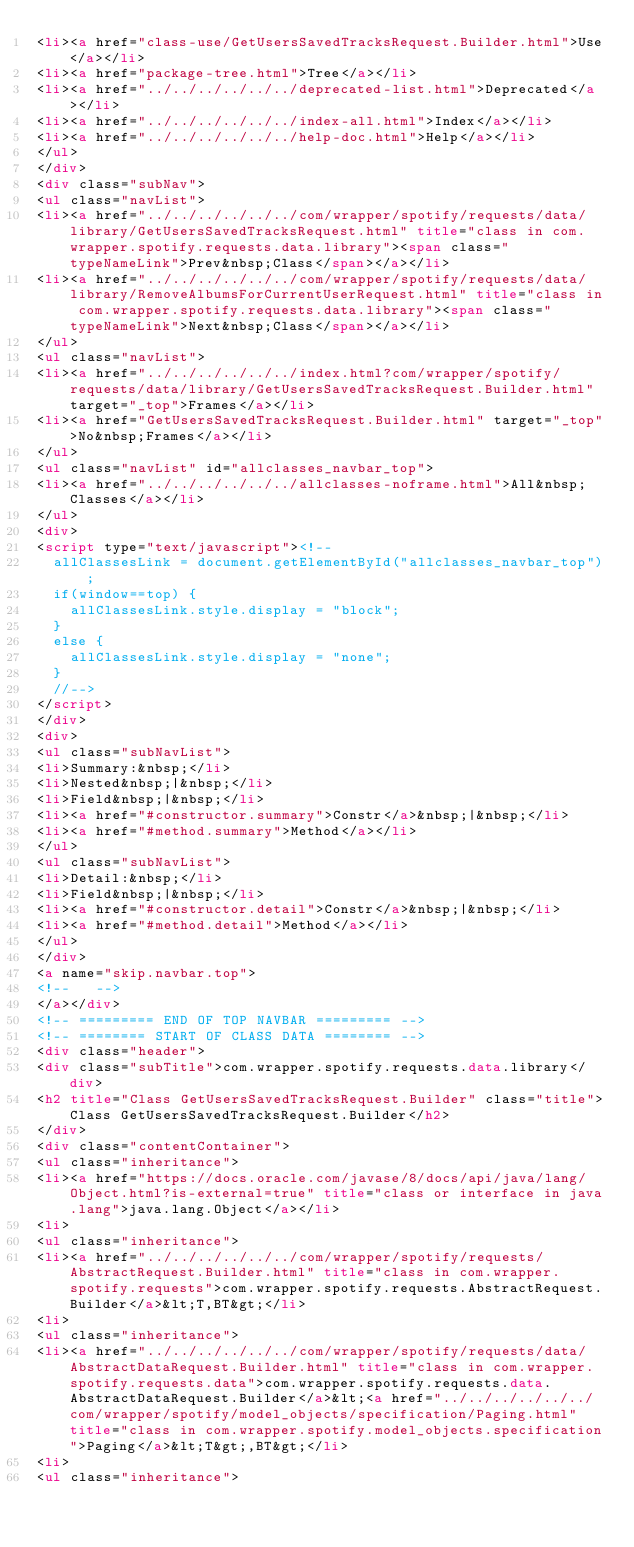<code> <loc_0><loc_0><loc_500><loc_500><_HTML_><li><a href="class-use/GetUsersSavedTracksRequest.Builder.html">Use</a></li>
<li><a href="package-tree.html">Tree</a></li>
<li><a href="../../../../../../deprecated-list.html">Deprecated</a></li>
<li><a href="../../../../../../index-all.html">Index</a></li>
<li><a href="../../../../../../help-doc.html">Help</a></li>
</ul>
</div>
<div class="subNav">
<ul class="navList">
<li><a href="../../../../../../com/wrapper/spotify/requests/data/library/GetUsersSavedTracksRequest.html" title="class in com.wrapper.spotify.requests.data.library"><span class="typeNameLink">Prev&nbsp;Class</span></a></li>
<li><a href="../../../../../../com/wrapper/spotify/requests/data/library/RemoveAlbumsForCurrentUserRequest.html" title="class in com.wrapper.spotify.requests.data.library"><span class="typeNameLink">Next&nbsp;Class</span></a></li>
</ul>
<ul class="navList">
<li><a href="../../../../../../index.html?com/wrapper/spotify/requests/data/library/GetUsersSavedTracksRequest.Builder.html" target="_top">Frames</a></li>
<li><a href="GetUsersSavedTracksRequest.Builder.html" target="_top">No&nbsp;Frames</a></li>
</ul>
<ul class="navList" id="allclasses_navbar_top">
<li><a href="../../../../../../allclasses-noframe.html">All&nbsp;Classes</a></li>
</ul>
<div>
<script type="text/javascript"><!--
  allClassesLink = document.getElementById("allclasses_navbar_top");
  if(window==top) {
    allClassesLink.style.display = "block";
  }
  else {
    allClassesLink.style.display = "none";
  }
  //-->
</script>
</div>
<div>
<ul class="subNavList">
<li>Summary:&nbsp;</li>
<li>Nested&nbsp;|&nbsp;</li>
<li>Field&nbsp;|&nbsp;</li>
<li><a href="#constructor.summary">Constr</a>&nbsp;|&nbsp;</li>
<li><a href="#method.summary">Method</a></li>
</ul>
<ul class="subNavList">
<li>Detail:&nbsp;</li>
<li>Field&nbsp;|&nbsp;</li>
<li><a href="#constructor.detail">Constr</a>&nbsp;|&nbsp;</li>
<li><a href="#method.detail">Method</a></li>
</ul>
</div>
<a name="skip.navbar.top">
<!--   -->
</a></div>
<!-- ========= END OF TOP NAVBAR ========= -->
<!-- ======== START OF CLASS DATA ======== -->
<div class="header">
<div class="subTitle">com.wrapper.spotify.requests.data.library</div>
<h2 title="Class GetUsersSavedTracksRequest.Builder" class="title">Class GetUsersSavedTracksRequest.Builder</h2>
</div>
<div class="contentContainer">
<ul class="inheritance">
<li><a href="https://docs.oracle.com/javase/8/docs/api/java/lang/Object.html?is-external=true" title="class or interface in java.lang">java.lang.Object</a></li>
<li>
<ul class="inheritance">
<li><a href="../../../../../../com/wrapper/spotify/requests/AbstractRequest.Builder.html" title="class in com.wrapper.spotify.requests">com.wrapper.spotify.requests.AbstractRequest.Builder</a>&lt;T,BT&gt;</li>
<li>
<ul class="inheritance">
<li><a href="../../../../../../com/wrapper/spotify/requests/data/AbstractDataRequest.Builder.html" title="class in com.wrapper.spotify.requests.data">com.wrapper.spotify.requests.data.AbstractDataRequest.Builder</a>&lt;<a href="../../../../../../com/wrapper/spotify/model_objects/specification/Paging.html" title="class in com.wrapper.spotify.model_objects.specification">Paging</a>&lt;T&gt;,BT&gt;</li>
<li>
<ul class="inheritance"></code> 